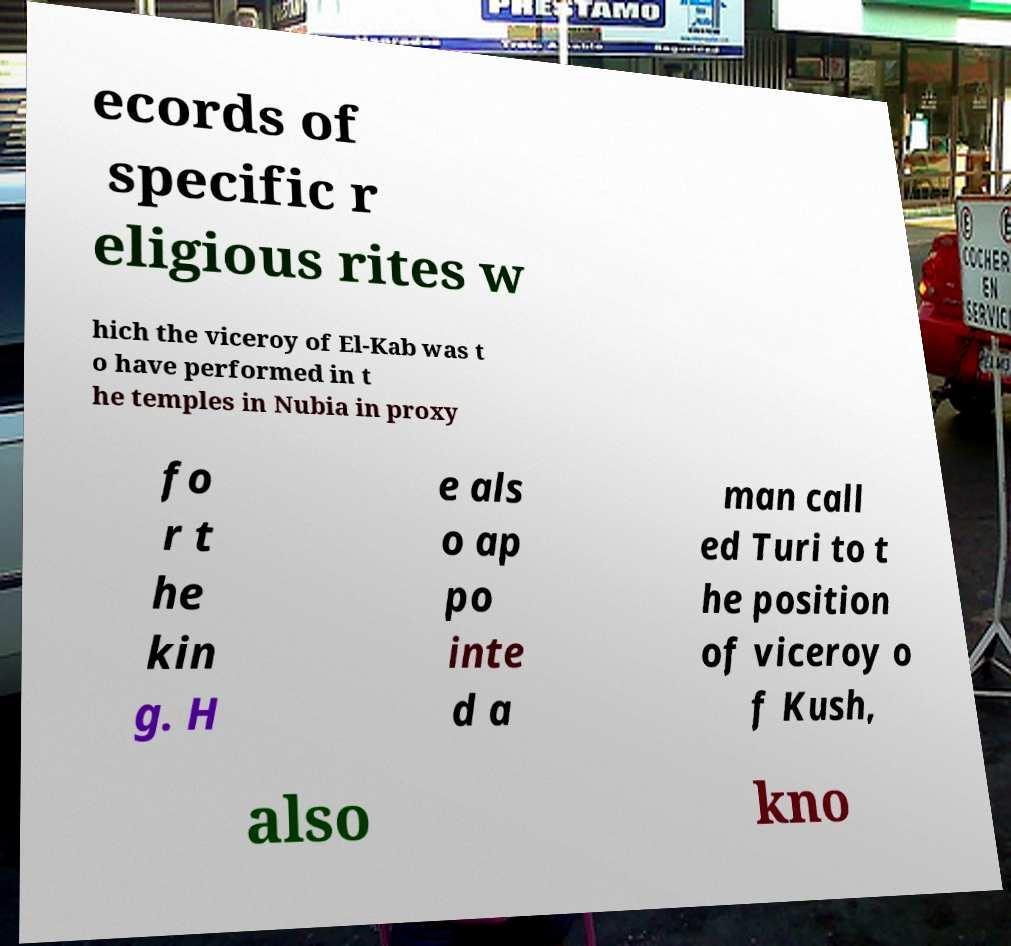Could you assist in decoding the text presented in this image and type it out clearly? ecords of specific r eligious rites w hich the viceroy of El-Kab was t o have performed in t he temples in Nubia in proxy fo r t he kin g. H e als o ap po inte d a man call ed Turi to t he position of viceroy o f Kush, also kno 